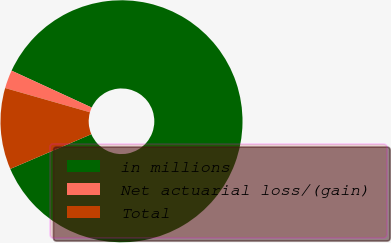Convert chart to OTSL. <chart><loc_0><loc_0><loc_500><loc_500><pie_chart><fcel>in millions<fcel>Net actuarial loss/(gain)<fcel>Total<nl><fcel>86.69%<fcel>2.44%<fcel>10.87%<nl></chart> 